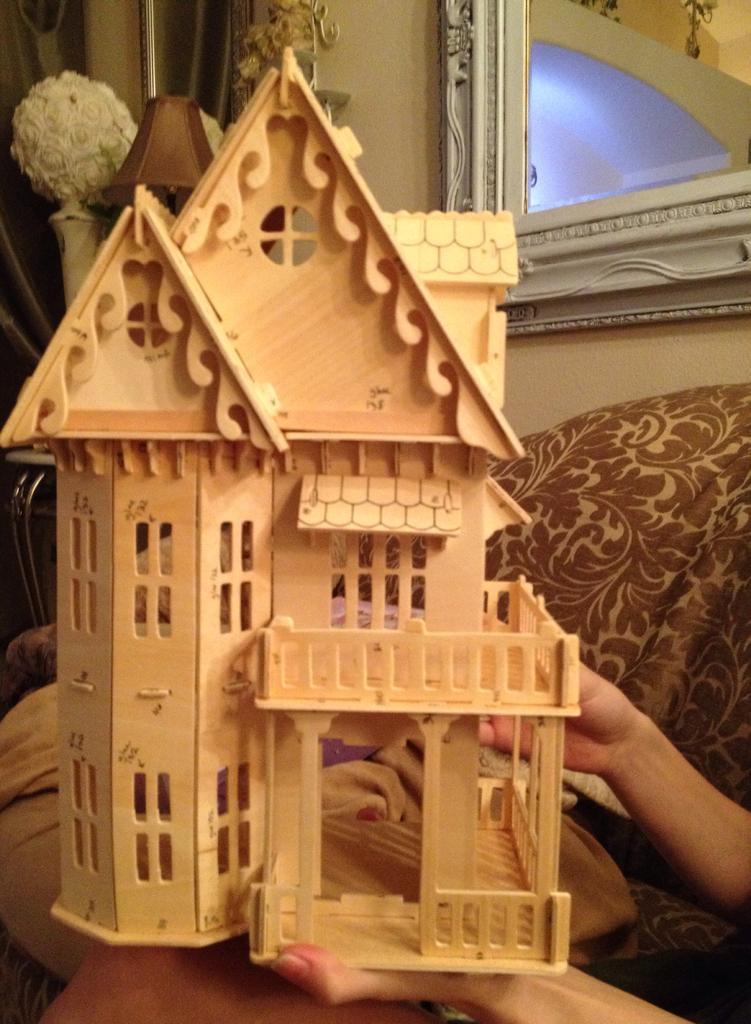Can you describe this image briefly? In the image we can see a toy house made up of wood and here we can see human hands. Here we can see the wall and frame stick to the wall. 